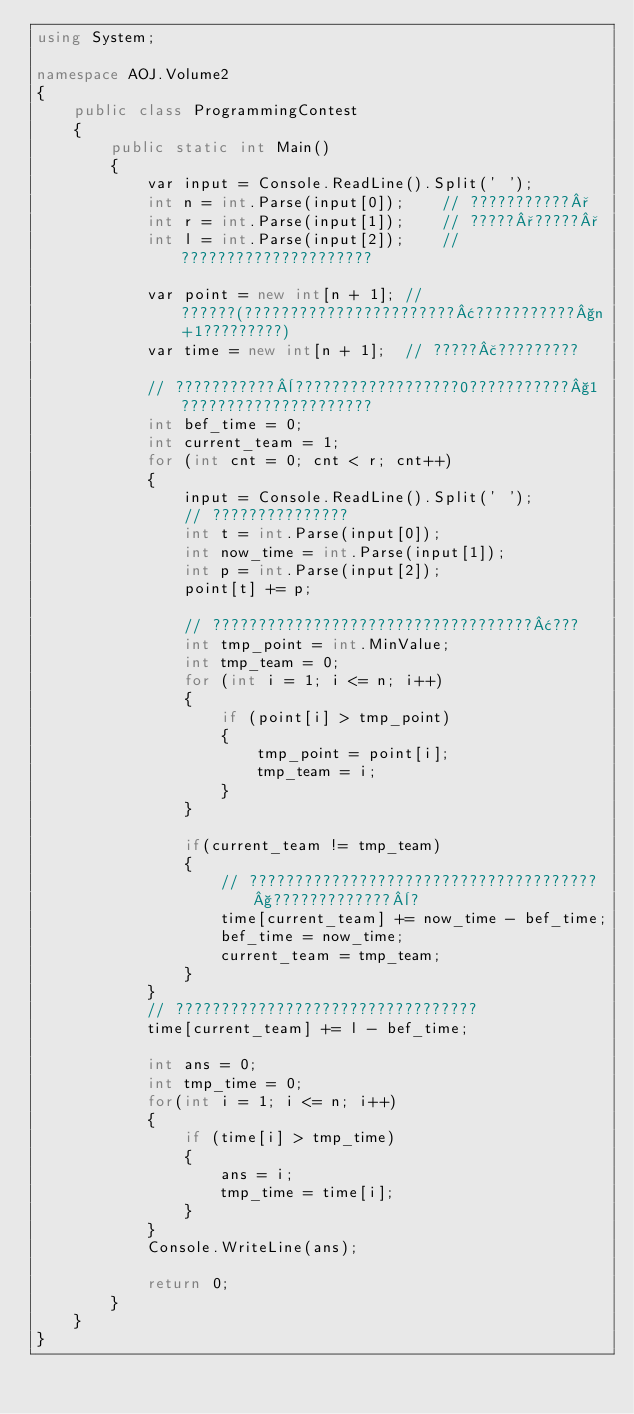Convert code to text. <code><loc_0><loc_0><loc_500><loc_500><_C#_>using System;

namespace AOJ.Volume2
{
    public class ProgrammingContest
    {
        public static int Main()
        {
            var input = Console.ReadLine().Split(' ');
            int n = int.Parse(input[0]);    // ???????????°
            int r = int.Parse(input[1]);    // ?????°?????°
            int l = int.Parse(input[2]);    // ?????????????????????

            var point = new int[n + 1]; // ??????(???????????????????????¢???????????§n+1?????????)
            var time = new int[n + 1];  // ?????£?????????

            // ???????????¨??????????????????0???????????§1?????????????????????
            int bef_time = 0;
            int current_team = 1;
            for (int cnt = 0; cnt < r; cnt++)
            {
                input = Console.ReadLine().Split(' ');
                // ???????????????
                int t = int.Parse(input[0]);
                int now_time = int.Parse(input[1]);
                int p = int.Parse(input[2]);
                point[t] += p;

                // ???????????????????????????????????¢???
                int tmp_point = int.MinValue;
                int tmp_team = 0;
                for (int i = 1; i <= n; i++)
                {
                    if (point[i] > tmp_point)
                    {
                        tmp_point = point[i];
                        tmp_team = i;
                    }
                }

                if(current_team != tmp_team)
                {
                    // ??????????????????????????????????????§?????????????¨?
                    time[current_team] += now_time - bef_time;
                    bef_time = now_time;
                    current_team = tmp_team;
                }
            }
            // ?????????????????????????????????
            time[current_team] += l - bef_time;

            int ans = 0;
            int tmp_time = 0;
            for(int i = 1; i <= n; i++)
            {
                if (time[i] > tmp_time)
                {
                    ans = i;
                    tmp_time = time[i];
                }
            }
            Console.WriteLine(ans);

            return 0;
        }
    }
}</code> 